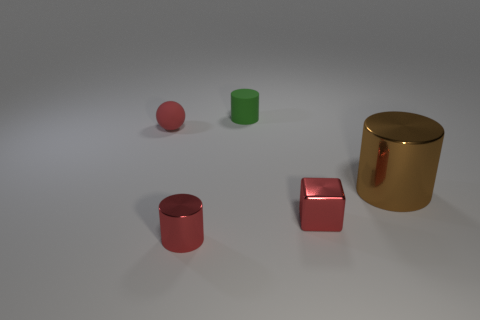What size is the block that is the same color as the small shiny cylinder?
Ensure brevity in your answer.  Small. The metal thing that is the same color as the tiny metallic cylinder is what shape?
Your answer should be compact. Cube. Are there any other things that are the same color as the small sphere?
Make the answer very short. Yes. What is the shape of the green object that is the same size as the matte ball?
Your answer should be compact. Cylinder. There is a ball that is the same size as the block; what material is it?
Make the answer very short. Rubber. Are any red cubes visible?
Provide a succinct answer. Yes. There is a tiny metal cylinder; does it have the same color as the tiny matte thing that is on the left side of the small green matte cylinder?
Your answer should be very brief. Yes. There is a cylinder that is the same color as the cube; what material is it?
Give a very brief answer. Metal. Are there any other things that have the same shape as the tiny red matte thing?
Keep it short and to the point. No. There is a rubber object that is left of the metal cylinder in front of the shiny cylinder that is behind the red cylinder; what shape is it?
Offer a very short reply. Sphere. 